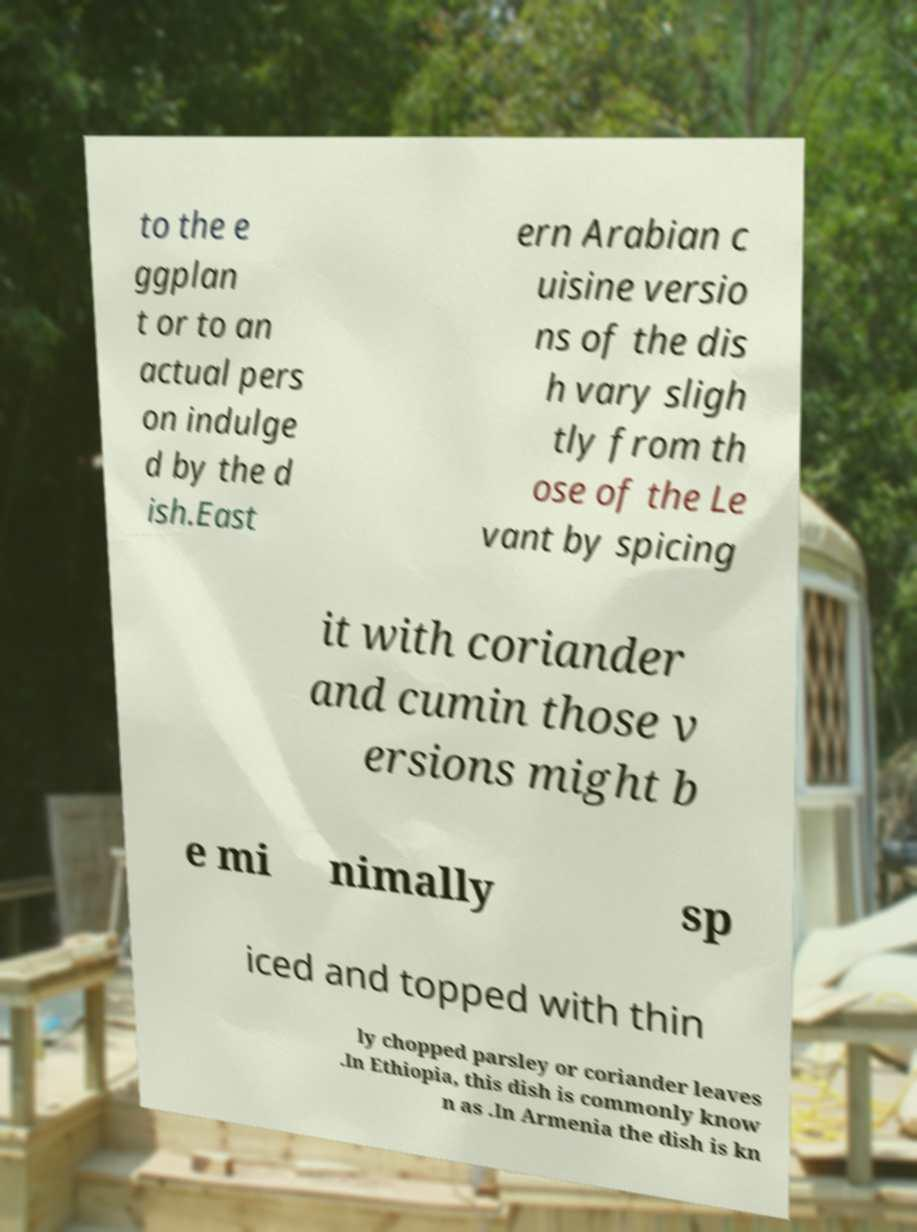Could you extract and type out the text from this image? to the e ggplan t or to an actual pers on indulge d by the d ish.East ern Arabian c uisine versio ns of the dis h vary sligh tly from th ose of the Le vant by spicing it with coriander and cumin those v ersions might b e mi nimally sp iced and topped with thin ly chopped parsley or coriander leaves .In Ethiopia, this dish is commonly know n as .In Armenia the dish is kn 